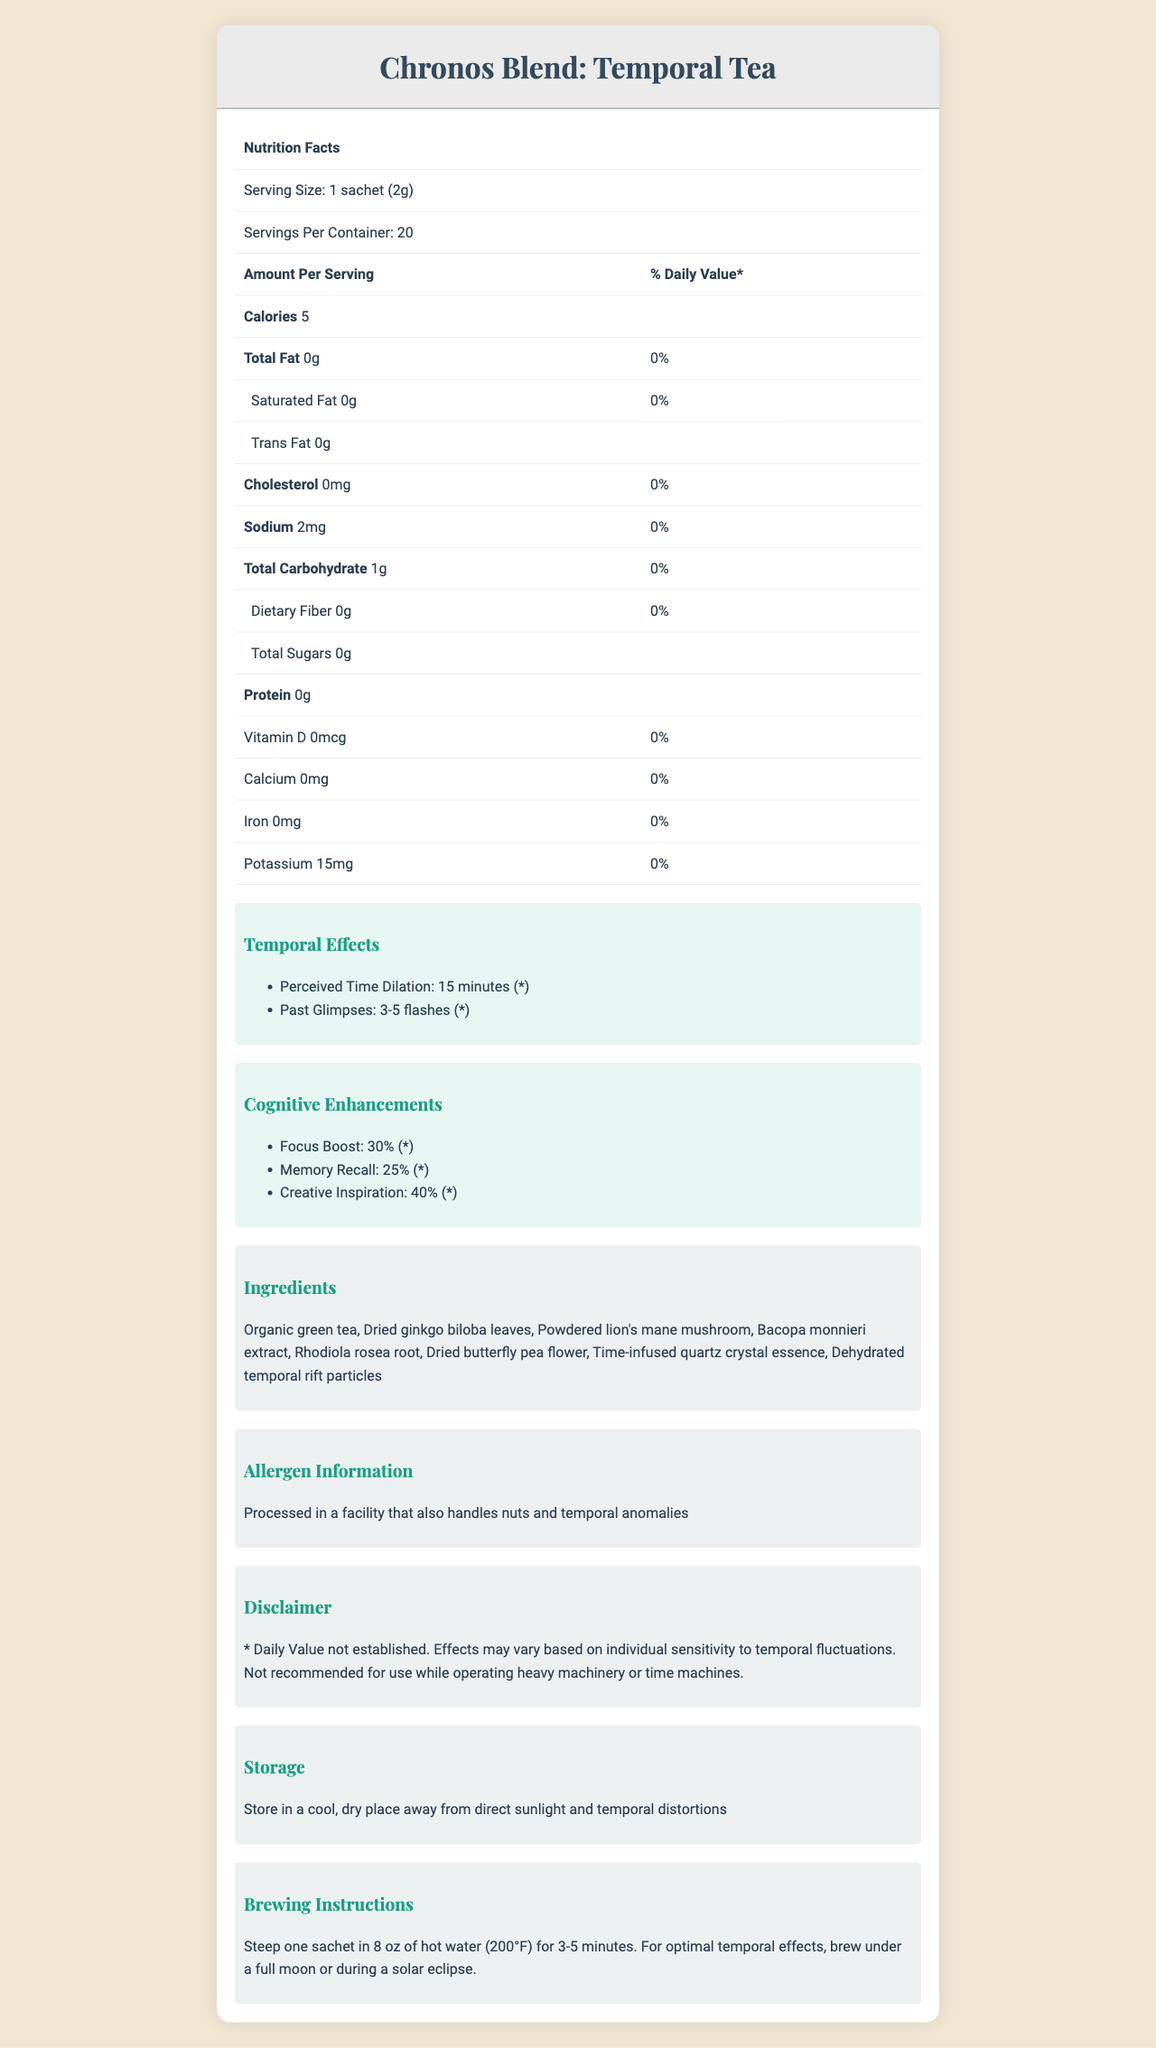What is the serving size of Chronos Blend: Temporal Tea? The serving size is explicitly mentioned in the document under the Nutritional Facts section.
Answer: 1 sachet (2g) How many servings are there in one container of Chronos Blend: Temporal Tea? The document states that there are 20 servings per container.
Answer: 20 What is the amount of sodium in one serving? According to the Nutritional Facts, one serving contains 2 mg of sodium.
Answer: 2 mg List two temporal effects of the Chronos Blend: Temporal Tea. The temporal effects listed in the document are Perceived Time Dilation and Past Glimpses.
Answer: 1. Perceived Time Dilation, 2. Past Glimpses Is there any protein in Chronos Blend: Temporal Tea? The Nutritional Facts section shows that the tea contains 0 grams of protein.
Answer: No, there is 0g protein What percentage of Focus Boost can be obtained from one serving of this tea? The Cognitive Enhancements section mentions that Focus Boost is 30%.
Answer: 30% Which of the following ingredients is NOT in the Chronos Blend: Temporal Tea? A. Organic green tea B. Dried ginkgo biloba leaves C. Lavender The document lists the ingredients, and Lavender is not included.
Answer: C How many calories are in one serving of the Chronos Blend: Temporal Tea? The calorie count per serving is listed as 5 in the Nutritional Facts section.
Answer: 5 True or False: The tea contains some cholesterol. The Nutritional Facts section lists 0 mg of cholesterol.
Answer: False Summarize the main idea of the document. The document includes comprehensive information about the Chronos Blend: Temporal Tea, focusing on its nutritional content, unique effects, ingredients, and handling instructions.
Answer: The document details the nutritional facts, ingredients, temporal and cognitive effects, and other relevant information about the Chronos Blend: Temporal Tea. It includes specific data about serving size, calories, various nutrients, and both unique temporal and cognitive enhancements. Additionally, it provides allergen information, storage and brewing instructions, emphasizing the product's extraordinary properties. Does this tea provide any daily values for vitamins or minerals? The Nutritional Facts section states that Vitamin D, calcium, iron, and potassium all have a 0% daily value.
Answer: No What effect does "Perceived Time Dilation" have, according to the document? The Temporal Effects section indicates that Perceived Time Dilation lasts for 15 minutes.
Answer: 15 minutes Can you use this tea while operating heavy machinery? The disclaimer specifically advises against the use of the tea while operating heavy machinery or time machines.
Answer: No Which of the following Cognitive Enhancements has the highest percentage? I. Focus Boost II. Memory Recall III. Creative Inspiration IV. Attention Span Creative Inspiration is listed with a 40% enhancement, which is the highest among the options given.
Answer: III Does this tea have any added sugars? The Nutritional Facts section shows Total Sugars as 0g, indicating no added sugars.
Answer: No What is the optimal brewing condition for temporal effects according to the document? The brewing instructions suggest optimal results when brewed under a full moon or during a solar eclipse.
Answer: Under a full moon or during a solar eclipse Does Chronos Blend: Temporal Tea contain Rhodiola rosea root? The document lists Rhodiola rosea root as one of the ingredients.
Answer: Yes How many flashes does "Past Glimpses" provide? The Temporal Effects section mentions that Past Glimpses consist of 3-5 flashes.
Answer: 3-5 flashes Name one cognitive enhancement provided by the Chronos Blend: Temporal Tea. The Cognitive Enhancements section lists Memory Recall as one of the enhancements.
Answer: Memory Recall What shipping weight is listed for Chronos Blend: Temporal Tea? The document does not provide information about the shipping weight.
Answer: I don't know 